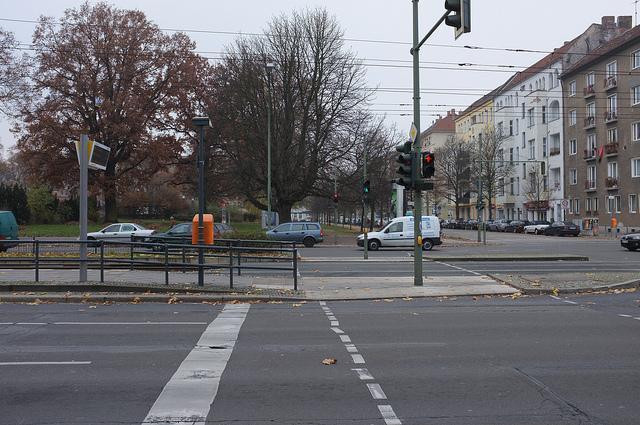How many people in this photo?
Give a very brief answer. 0. How many light blue umbrellas are in the image?
Give a very brief answer. 0. 